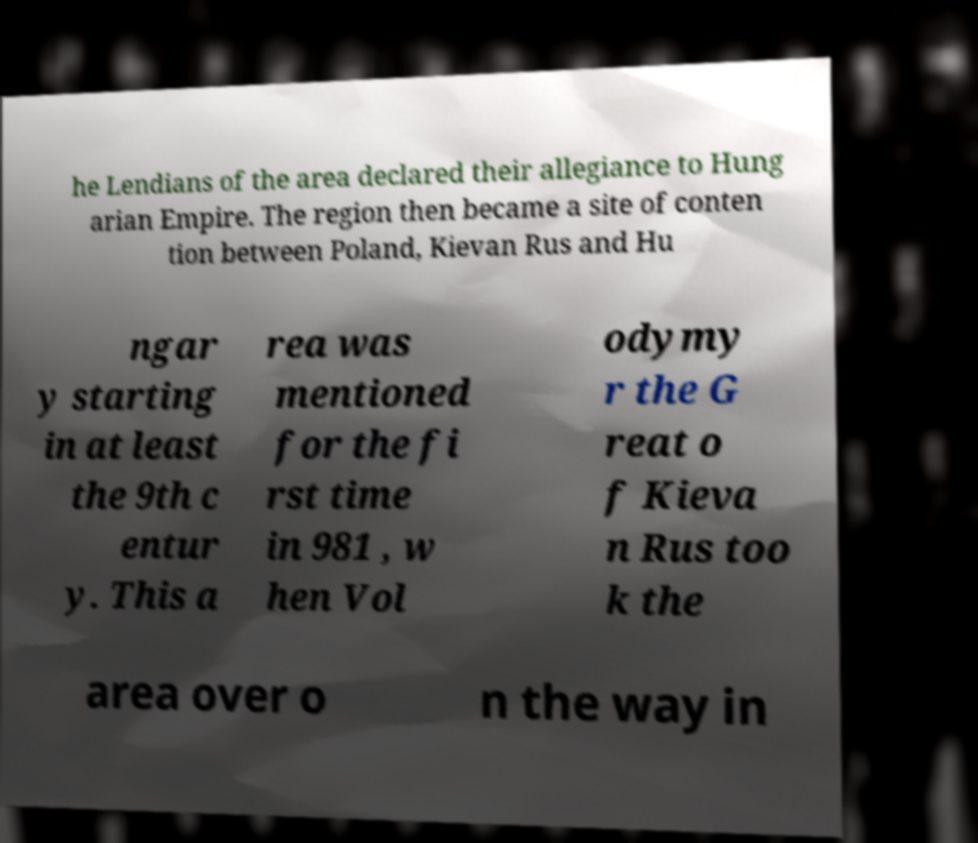What messages or text are displayed in this image? I need them in a readable, typed format. he Lendians of the area declared their allegiance to Hung arian Empire. The region then became a site of conten tion between Poland, Kievan Rus and Hu ngar y starting in at least the 9th c entur y. This a rea was mentioned for the fi rst time in 981 , w hen Vol odymy r the G reat o f Kieva n Rus too k the area over o n the way in 